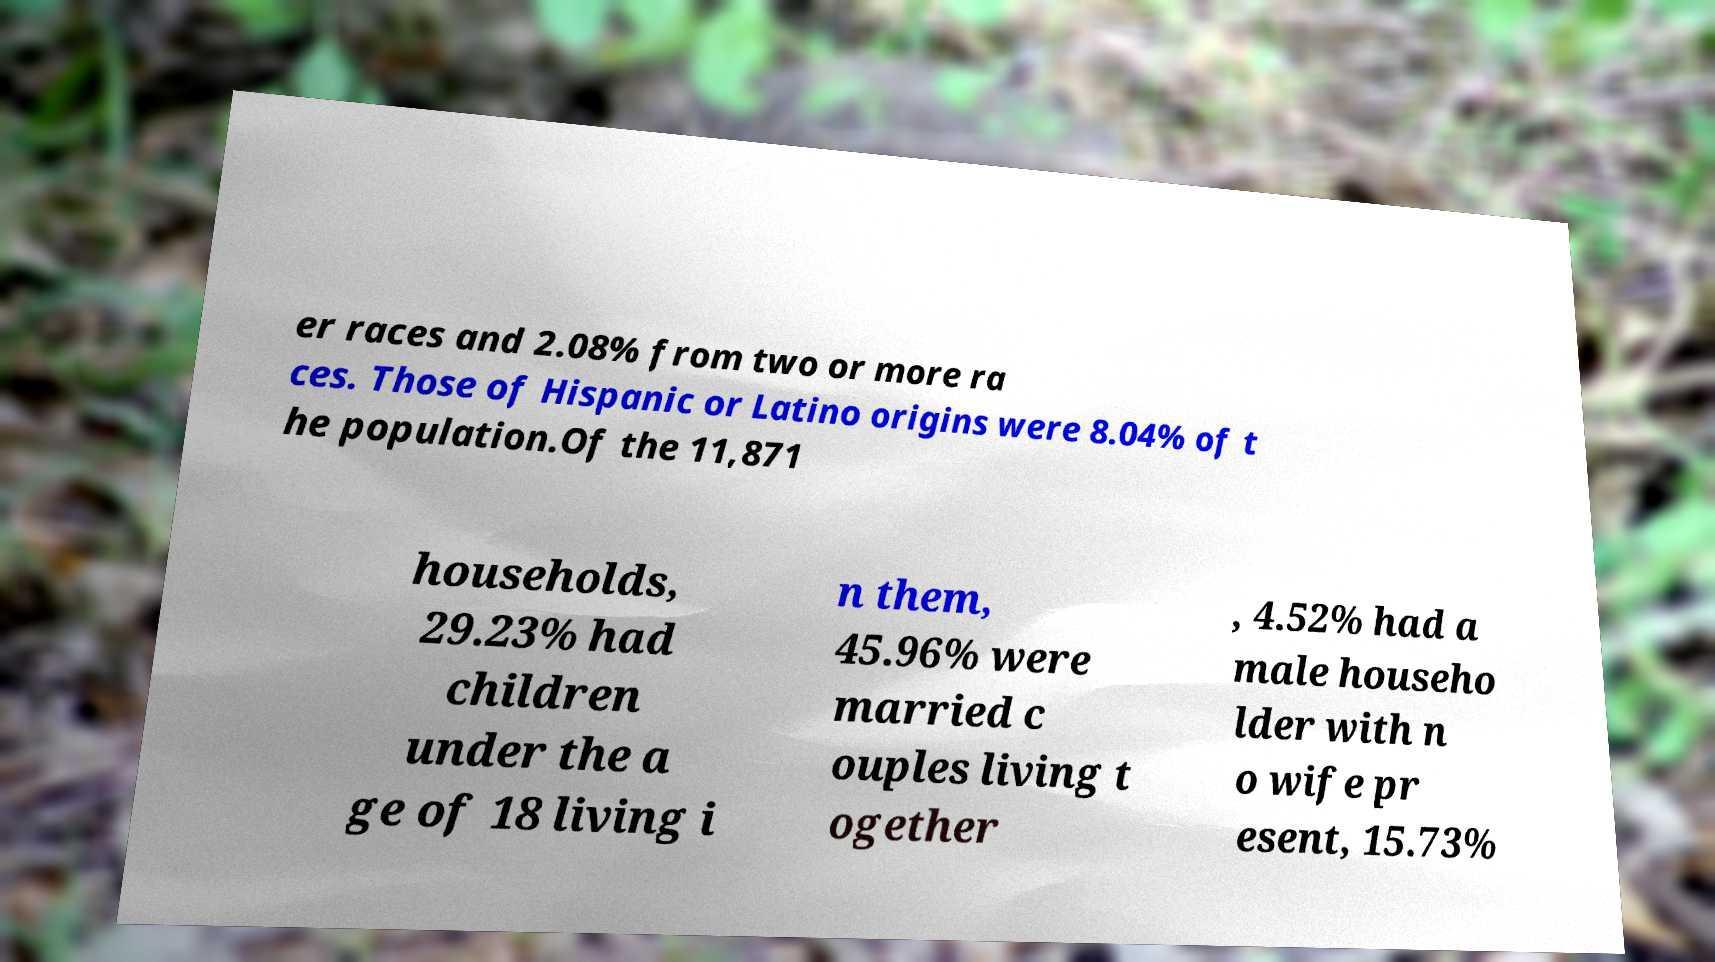Can you read and provide the text displayed in the image?This photo seems to have some interesting text. Can you extract and type it out for me? er races and 2.08% from two or more ra ces. Those of Hispanic or Latino origins were 8.04% of t he population.Of the 11,871 households, 29.23% had children under the a ge of 18 living i n them, 45.96% were married c ouples living t ogether , 4.52% had a male househo lder with n o wife pr esent, 15.73% 